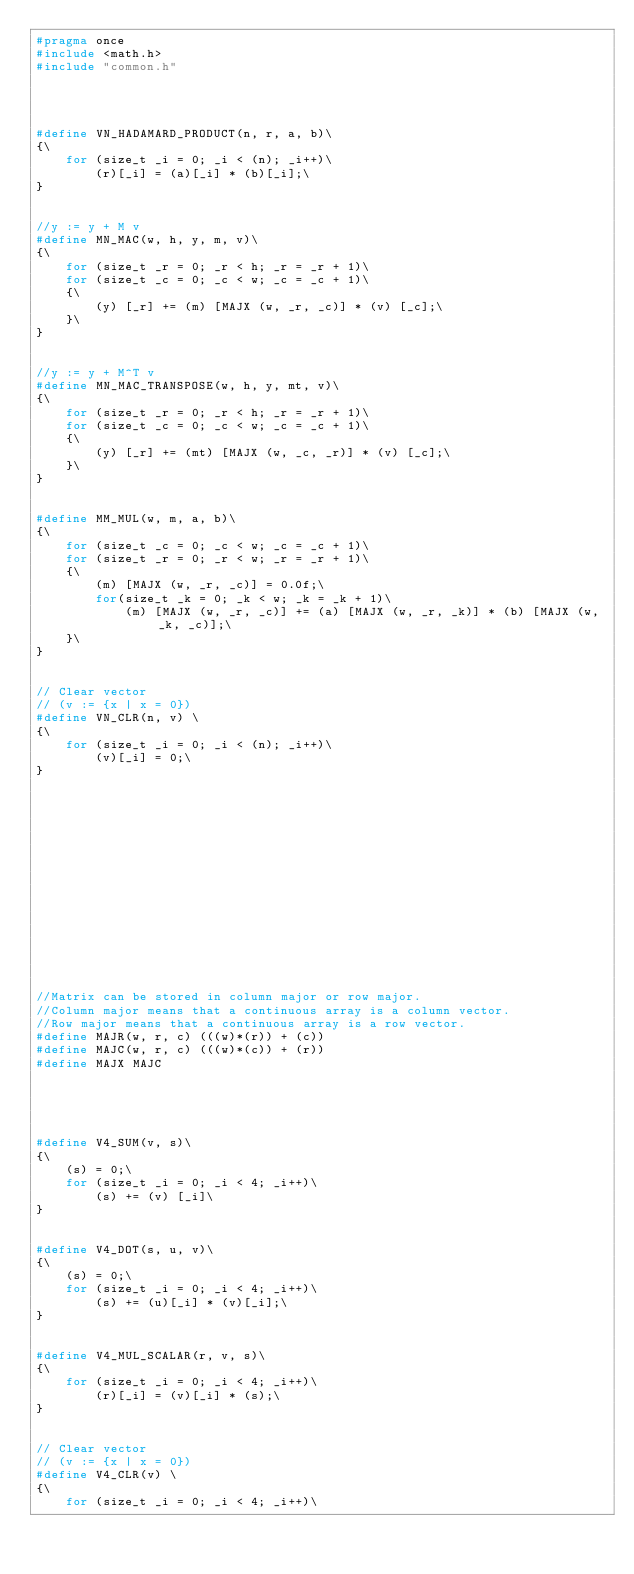<code> <loc_0><loc_0><loc_500><loc_500><_C_>#pragma once
#include <math.h>
#include "common.h"




#define VN_HADAMARD_PRODUCT(n, r, a, b)\
{\
    for (size_t _i = 0; _i < (n); _i++)\
        (r)[_i] = (a)[_i] * (b)[_i];\
}


//y := y + M v
#define MN_MAC(w, h, y, m, v)\
{\
	for (size_t _r = 0; _r < h; _r = _r + 1)\
	for (size_t _c = 0; _c < w; _c = _c + 1)\
	{\
		(y) [_r] += (m) [MAJX (w, _r, _c)] * (v) [_c];\
	}\
}


//y := y + M^T v
#define MN_MAC_TRANSPOSE(w, h, y, mt, v)\
{\
	for (size_t _r = 0; _r < h; _r = _r + 1)\
	for (size_t _c = 0; _c < w; _c = _c + 1)\
	{\
		(y) [_r] += (mt) [MAJX (w, _c, _r)] * (v) [_c];\
	}\
}


#define MM_MUL(w, m, a, b)\
{\
	for (size_t _c = 0; _c < w; _c = _c + 1)\
	for (size_t _r = 0; _r < w; _r = _r + 1)\
	{\
		(m) [MAJX (w, _r, _c)] = 0.0f;\
		for(size_t _k = 0; _k < w; _k = _k + 1)\
			(m) [MAJX (w, _r, _c)] += (a) [MAJX (w, _r, _k)] * (b) [MAJX (w, _k, _c)];\
	}\
}


// Clear vector
// (v := {x | x = 0})
#define VN_CLR(n, v) \
{\
	for (size_t _i = 0; _i < (n); _i++)\
		(v)[_i] = 0;\
}
















//Matrix can be stored in column major or row major.
//Column major means that a continuous array is a column vector.
//Row major means that a continuous array is a row vector.
#define MAJR(w, r, c) (((w)*(r)) + (c))
#define MAJC(w, r, c) (((w)*(c)) + (r))
#define MAJX MAJC





#define V4_SUM(v, s)\
{\
	(s) = 0;\
    for (size_t _i = 0; _i < 4; _i++)\
        (s) += (v) [_i]\
}


#define V4_DOT(s, u, v)\
{\
    (s) = 0;\
    for (size_t _i = 0; _i < 4; _i++)\
        (s) += (u)[_i] * (v)[_i];\
}


#define V4_MUL_SCALAR(r, v, s)\
{\
    for (size_t _i = 0; _i < 4; _i++)\
        (r)[_i] = (v)[_i] * (s);\
}


// Clear vector
// (v := {x | x = 0})
#define V4_CLR(v) \
{\
	for (size_t _i = 0; _i < 4; _i++)\</code> 